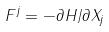<formula> <loc_0><loc_0><loc_500><loc_500>F ^ { j } = - \partial H / \partial X _ { j }</formula> 